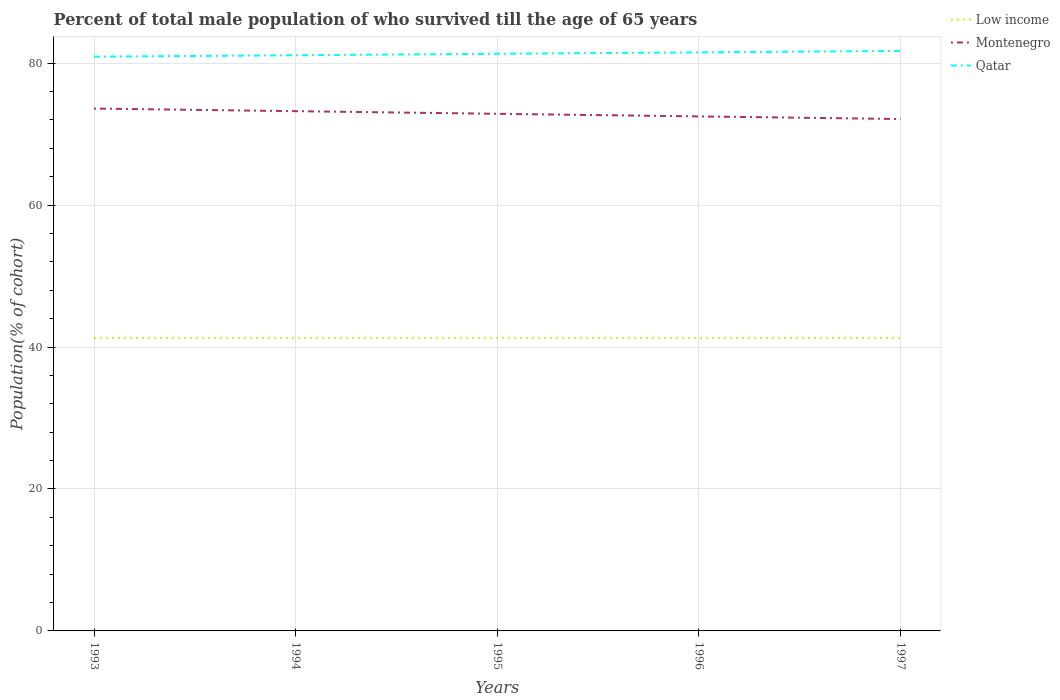Across all years, what is the maximum percentage of total male population who survived till the age of 65 years in Qatar?
Provide a succinct answer. 80.91. What is the total percentage of total male population who survived till the age of 65 years in Low income in the graph?
Your answer should be compact. -0.01. What is the difference between the highest and the second highest percentage of total male population who survived till the age of 65 years in Qatar?
Keep it short and to the point. 0.81. Is the percentage of total male population who survived till the age of 65 years in Low income strictly greater than the percentage of total male population who survived till the age of 65 years in Montenegro over the years?
Your answer should be compact. Yes. What is the difference between two consecutive major ticks on the Y-axis?
Ensure brevity in your answer.  20. Does the graph contain any zero values?
Keep it short and to the point. No. Does the graph contain grids?
Your answer should be compact. Yes. How many legend labels are there?
Provide a short and direct response. 3. What is the title of the graph?
Your answer should be compact. Percent of total male population of who survived till the age of 65 years. What is the label or title of the Y-axis?
Offer a terse response. Population(% of cohort). What is the Population(% of cohort) of Low income in 1993?
Provide a succinct answer. 41.28. What is the Population(% of cohort) in Montenegro in 1993?
Offer a very short reply. 73.6. What is the Population(% of cohort) of Qatar in 1993?
Keep it short and to the point. 80.91. What is the Population(% of cohort) in Low income in 1994?
Offer a very short reply. 41.29. What is the Population(% of cohort) in Montenegro in 1994?
Your answer should be compact. 73.23. What is the Population(% of cohort) of Qatar in 1994?
Make the answer very short. 81.11. What is the Population(% of cohort) of Low income in 1995?
Provide a succinct answer. 41.29. What is the Population(% of cohort) in Montenegro in 1995?
Provide a succinct answer. 72.86. What is the Population(% of cohort) in Qatar in 1995?
Ensure brevity in your answer.  81.31. What is the Population(% of cohort) of Low income in 1996?
Keep it short and to the point. 41.28. What is the Population(% of cohort) of Montenegro in 1996?
Keep it short and to the point. 72.49. What is the Population(% of cohort) of Qatar in 1996?
Provide a succinct answer. 81.51. What is the Population(% of cohort) in Low income in 1997?
Offer a terse response. 41.27. What is the Population(% of cohort) of Montenegro in 1997?
Ensure brevity in your answer.  72.12. What is the Population(% of cohort) of Qatar in 1997?
Your response must be concise. 81.72. Across all years, what is the maximum Population(% of cohort) in Low income?
Your response must be concise. 41.29. Across all years, what is the maximum Population(% of cohort) in Montenegro?
Keep it short and to the point. 73.6. Across all years, what is the maximum Population(% of cohort) of Qatar?
Give a very brief answer. 81.72. Across all years, what is the minimum Population(% of cohort) in Low income?
Make the answer very short. 41.27. Across all years, what is the minimum Population(% of cohort) of Montenegro?
Your answer should be compact. 72.12. Across all years, what is the minimum Population(% of cohort) in Qatar?
Ensure brevity in your answer.  80.91. What is the total Population(% of cohort) in Low income in the graph?
Give a very brief answer. 206.41. What is the total Population(% of cohort) in Montenegro in the graph?
Give a very brief answer. 364.29. What is the total Population(% of cohort) of Qatar in the graph?
Give a very brief answer. 406.56. What is the difference between the Population(% of cohort) of Low income in 1993 and that in 1994?
Make the answer very short. -0.01. What is the difference between the Population(% of cohort) in Montenegro in 1993 and that in 1994?
Provide a succinct answer. 0.37. What is the difference between the Population(% of cohort) of Qatar in 1993 and that in 1994?
Make the answer very short. -0.2. What is the difference between the Population(% of cohort) in Low income in 1993 and that in 1995?
Give a very brief answer. -0.01. What is the difference between the Population(% of cohort) of Montenegro in 1993 and that in 1995?
Provide a succinct answer. 0.74. What is the difference between the Population(% of cohort) in Qatar in 1993 and that in 1995?
Your answer should be very brief. -0.4. What is the difference between the Population(% of cohort) of Low income in 1993 and that in 1996?
Your response must be concise. -0.01. What is the difference between the Population(% of cohort) in Montenegro in 1993 and that in 1996?
Give a very brief answer. 1.11. What is the difference between the Population(% of cohort) of Qatar in 1993 and that in 1996?
Offer a very short reply. -0.61. What is the difference between the Population(% of cohort) in Low income in 1993 and that in 1997?
Provide a succinct answer. 0. What is the difference between the Population(% of cohort) of Montenegro in 1993 and that in 1997?
Give a very brief answer. 1.48. What is the difference between the Population(% of cohort) of Qatar in 1993 and that in 1997?
Ensure brevity in your answer.  -0.81. What is the difference between the Population(% of cohort) of Low income in 1994 and that in 1995?
Give a very brief answer. -0. What is the difference between the Population(% of cohort) of Montenegro in 1994 and that in 1995?
Your answer should be compact. 0.37. What is the difference between the Population(% of cohort) in Qatar in 1994 and that in 1995?
Your answer should be compact. -0.2. What is the difference between the Population(% of cohort) in Low income in 1994 and that in 1996?
Your answer should be compact. 0.01. What is the difference between the Population(% of cohort) in Montenegro in 1994 and that in 1996?
Your response must be concise. 0.74. What is the difference between the Population(% of cohort) in Qatar in 1994 and that in 1996?
Give a very brief answer. -0.4. What is the difference between the Population(% of cohort) of Low income in 1994 and that in 1997?
Provide a short and direct response. 0.02. What is the difference between the Population(% of cohort) in Montenegro in 1994 and that in 1997?
Your answer should be very brief. 1.11. What is the difference between the Population(% of cohort) of Qatar in 1994 and that in 1997?
Keep it short and to the point. -0.61. What is the difference between the Population(% of cohort) of Low income in 1995 and that in 1996?
Your answer should be very brief. 0.01. What is the difference between the Population(% of cohort) in Montenegro in 1995 and that in 1996?
Offer a terse response. 0.37. What is the difference between the Population(% of cohort) of Qatar in 1995 and that in 1996?
Offer a very short reply. -0.2. What is the difference between the Population(% of cohort) of Low income in 1995 and that in 1997?
Offer a very short reply. 0.02. What is the difference between the Population(% of cohort) in Montenegro in 1995 and that in 1997?
Keep it short and to the point. 0.74. What is the difference between the Population(% of cohort) in Qatar in 1995 and that in 1997?
Offer a terse response. -0.4. What is the difference between the Population(% of cohort) in Low income in 1996 and that in 1997?
Give a very brief answer. 0.01. What is the difference between the Population(% of cohort) in Montenegro in 1996 and that in 1997?
Your answer should be compact. 0.37. What is the difference between the Population(% of cohort) of Qatar in 1996 and that in 1997?
Offer a very short reply. -0.2. What is the difference between the Population(% of cohort) of Low income in 1993 and the Population(% of cohort) of Montenegro in 1994?
Make the answer very short. -31.95. What is the difference between the Population(% of cohort) in Low income in 1993 and the Population(% of cohort) in Qatar in 1994?
Provide a succinct answer. -39.83. What is the difference between the Population(% of cohort) of Montenegro in 1993 and the Population(% of cohort) of Qatar in 1994?
Offer a terse response. -7.51. What is the difference between the Population(% of cohort) of Low income in 1993 and the Population(% of cohort) of Montenegro in 1995?
Your response must be concise. -31.58. What is the difference between the Population(% of cohort) of Low income in 1993 and the Population(% of cohort) of Qatar in 1995?
Provide a short and direct response. -40.03. What is the difference between the Population(% of cohort) of Montenegro in 1993 and the Population(% of cohort) of Qatar in 1995?
Give a very brief answer. -7.72. What is the difference between the Population(% of cohort) in Low income in 1993 and the Population(% of cohort) in Montenegro in 1996?
Offer a very short reply. -31.21. What is the difference between the Population(% of cohort) of Low income in 1993 and the Population(% of cohort) of Qatar in 1996?
Provide a short and direct response. -40.24. What is the difference between the Population(% of cohort) of Montenegro in 1993 and the Population(% of cohort) of Qatar in 1996?
Offer a very short reply. -7.92. What is the difference between the Population(% of cohort) of Low income in 1993 and the Population(% of cohort) of Montenegro in 1997?
Your response must be concise. -30.84. What is the difference between the Population(% of cohort) in Low income in 1993 and the Population(% of cohort) in Qatar in 1997?
Offer a terse response. -40.44. What is the difference between the Population(% of cohort) in Montenegro in 1993 and the Population(% of cohort) in Qatar in 1997?
Provide a short and direct response. -8.12. What is the difference between the Population(% of cohort) of Low income in 1994 and the Population(% of cohort) of Montenegro in 1995?
Provide a short and direct response. -31.57. What is the difference between the Population(% of cohort) in Low income in 1994 and the Population(% of cohort) in Qatar in 1995?
Your answer should be compact. -40.02. What is the difference between the Population(% of cohort) in Montenegro in 1994 and the Population(% of cohort) in Qatar in 1995?
Make the answer very short. -8.08. What is the difference between the Population(% of cohort) in Low income in 1994 and the Population(% of cohort) in Montenegro in 1996?
Your response must be concise. -31.2. What is the difference between the Population(% of cohort) in Low income in 1994 and the Population(% of cohort) in Qatar in 1996?
Provide a succinct answer. -40.22. What is the difference between the Population(% of cohort) of Montenegro in 1994 and the Population(% of cohort) of Qatar in 1996?
Offer a very short reply. -8.29. What is the difference between the Population(% of cohort) of Low income in 1994 and the Population(% of cohort) of Montenegro in 1997?
Provide a succinct answer. -30.83. What is the difference between the Population(% of cohort) in Low income in 1994 and the Population(% of cohort) in Qatar in 1997?
Keep it short and to the point. -40.43. What is the difference between the Population(% of cohort) in Montenegro in 1994 and the Population(% of cohort) in Qatar in 1997?
Offer a very short reply. -8.49. What is the difference between the Population(% of cohort) of Low income in 1995 and the Population(% of cohort) of Montenegro in 1996?
Offer a very short reply. -31.2. What is the difference between the Population(% of cohort) in Low income in 1995 and the Population(% of cohort) in Qatar in 1996?
Keep it short and to the point. -40.22. What is the difference between the Population(% of cohort) of Montenegro in 1995 and the Population(% of cohort) of Qatar in 1996?
Offer a terse response. -8.66. What is the difference between the Population(% of cohort) of Low income in 1995 and the Population(% of cohort) of Montenegro in 1997?
Provide a short and direct response. -30.83. What is the difference between the Population(% of cohort) of Low income in 1995 and the Population(% of cohort) of Qatar in 1997?
Your answer should be compact. -40.42. What is the difference between the Population(% of cohort) of Montenegro in 1995 and the Population(% of cohort) of Qatar in 1997?
Your answer should be very brief. -8.86. What is the difference between the Population(% of cohort) in Low income in 1996 and the Population(% of cohort) in Montenegro in 1997?
Your response must be concise. -30.84. What is the difference between the Population(% of cohort) in Low income in 1996 and the Population(% of cohort) in Qatar in 1997?
Your answer should be very brief. -40.43. What is the difference between the Population(% of cohort) in Montenegro in 1996 and the Population(% of cohort) in Qatar in 1997?
Provide a short and direct response. -9.23. What is the average Population(% of cohort) in Low income per year?
Ensure brevity in your answer.  41.28. What is the average Population(% of cohort) of Montenegro per year?
Ensure brevity in your answer.  72.86. What is the average Population(% of cohort) in Qatar per year?
Your answer should be compact. 81.31. In the year 1993, what is the difference between the Population(% of cohort) of Low income and Population(% of cohort) of Montenegro?
Your answer should be very brief. -32.32. In the year 1993, what is the difference between the Population(% of cohort) in Low income and Population(% of cohort) in Qatar?
Provide a short and direct response. -39.63. In the year 1993, what is the difference between the Population(% of cohort) of Montenegro and Population(% of cohort) of Qatar?
Offer a terse response. -7.31. In the year 1994, what is the difference between the Population(% of cohort) of Low income and Population(% of cohort) of Montenegro?
Give a very brief answer. -31.94. In the year 1994, what is the difference between the Population(% of cohort) in Low income and Population(% of cohort) in Qatar?
Offer a terse response. -39.82. In the year 1994, what is the difference between the Population(% of cohort) of Montenegro and Population(% of cohort) of Qatar?
Offer a terse response. -7.88. In the year 1995, what is the difference between the Population(% of cohort) of Low income and Population(% of cohort) of Montenegro?
Make the answer very short. -31.57. In the year 1995, what is the difference between the Population(% of cohort) in Low income and Population(% of cohort) in Qatar?
Your response must be concise. -40.02. In the year 1995, what is the difference between the Population(% of cohort) in Montenegro and Population(% of cohort) in Qatar?
Provide a succinct answer. -8.45. In the year 1996, what is the difference between the Population(% of cohort) of Low income and Population(% of cohort) of Montenegro?
Provide a short and direct response. -31.21. In the year 1996, what is the difference between the Population(% of cohort) in Low income and Population(% of cohort) in Qatar?
Keep it short and to the point. -40.23. In the year 1996, what is the difference between the Population(% of cohort) of Montenegro and Population(% of cohort) of Qatar?
Keep it short and to the point. -9.02. In the year 1997, what is the difference between the Population(% of cohort) in Low income and Population(% of cohort) in Montenegro?
Keep it short and to the point. -30.85. In the year 1997, what is the difference between the Population(% of cohort) in Low income and Population(% of cohort) in Qatar?
Your response must be concise. -40.44. In the year 1997, what is the difference between the Population(% of cohort) in Montenegro and Population(% of cohort) in Qatar?
Provide a succinct answer. -9.6. What is the ratio of the Population(% of cohort) in Qatar in 1993 to that in 1994?
Keep it short and to the point. 1. What is the ratio of the Population(% of cohort) in Qatar in 1993 to that in 1995?
Make the answer very short. 0.99. What is the ratio of the Population(% of cohort) in Low income in 1993 to that in 1996?
Make the answer very short. 1. What is the ratio of the Population(% of cohort) of Montenegro in 1993 to that in 1996?
Keep it short and to the point. 1.02. What is the ratio of the Population(% of cohort) in Low income in 1993 to that in 1997?
Your answer should be very brief. 1. What is the ratio of the Population(% of cohort) in Montenegro in 1993 to that in 1997?
Offer a very short reply. 1.02. What is the ratio of the Population(% of cohort) in Low income in 1994 to that in 1995?
Give a very brief answer. 1. What is the ratio of the Population(% of cohort) of Low income in 1994 to that in 1996?
Provide a succinct answer. 1. What is the ratio of the Population(% of cohort) of Montenegro in 1994 to that in 1996?
Offer a very short reply. 1.01. What is the ratio of the Population(% of cohort) of Qatar in 1994 to that in 1996?
Provide a short and direct response. 0.99. What is the ratio of the Population(% of cohort) of Montenegro in 1994 to that in 1997?
Make the answer very short. 1.02. What is the ratio of the Population(% of cohort) in Low income in 1995 to that in 1996?
Ensure brevity in your answer.  1. What is the ratio of the Population(% of cohort) of Low income in 1995 to that in 1997?
Ensure brevity in your answer.  1. What is the ratio of the Population(% of cohort) of Montenegro in 1995 to that in 1997?
Provide a succinct answer. 1.01. What is the ratio of the Population(% of cohort) in Qatar in 1995 to that in 1997?
Provide a succinct answer. 1. What is the difference between the highest and the second highest Population(% of cohort) of Low income?
Provide a succinct answer. 0. What is the difference between the highest and the second highest Population(% of cohort) in Montenegro?
Your answer should be compact. 0.37. What is the difference between the highest and the second highest Population(% of cohort) in Qatar?
Make the answer very short. 0.2. What is the difference between the highest and the lowest Population(% of cohort) of Low income?
Ensure brevity in your answer.  0.02. What is the difference between the highest and the lowest Population(% of cohort) of Montenegro?
Make the answer very short. 1.48. What is the difference between the highest and the lowest Population(% of cohort) of Qatar?
Offer a very short reply. 0.81. 